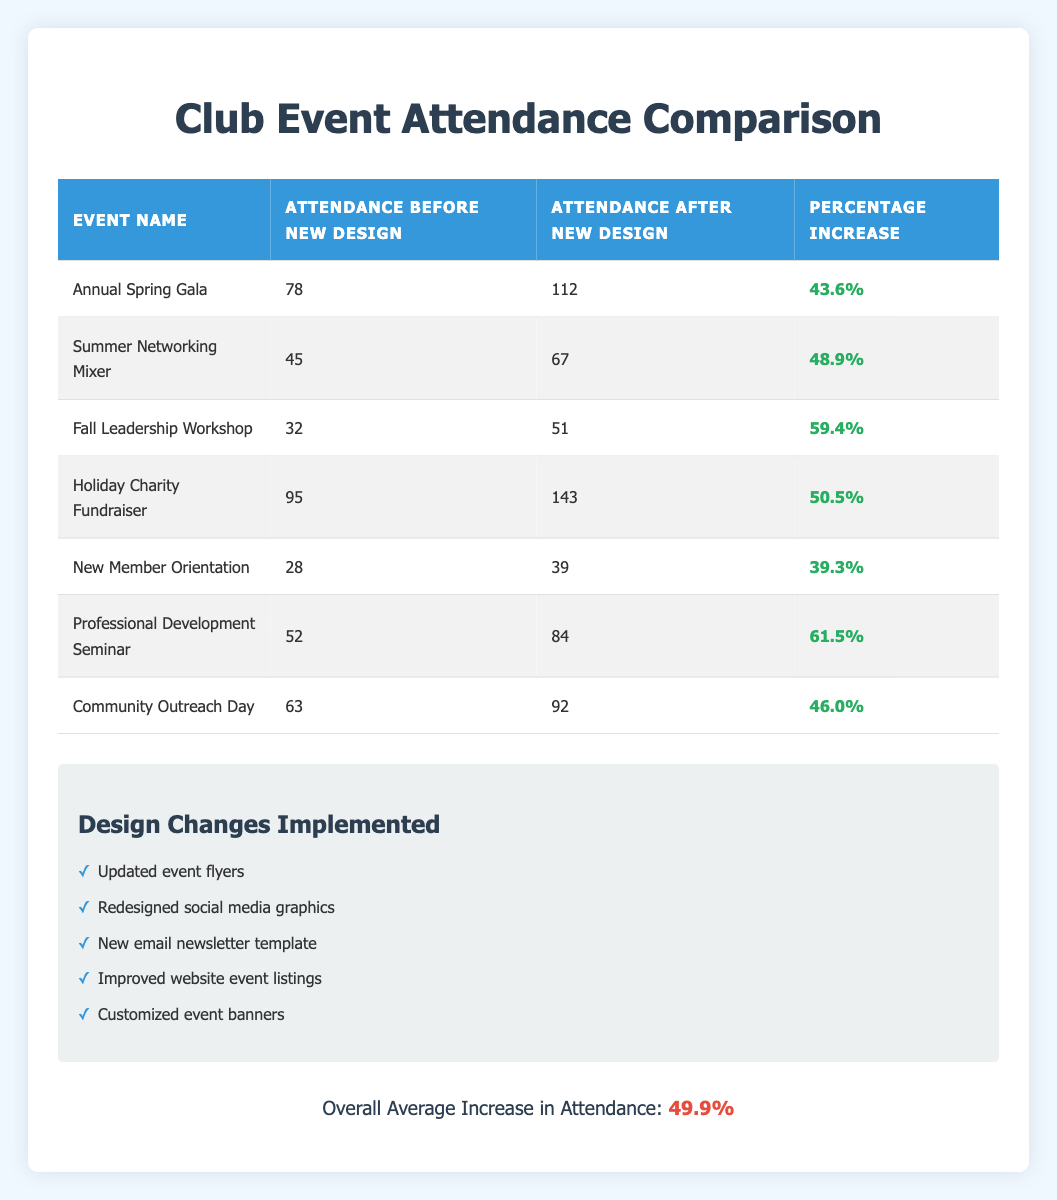What was the attendance for the Annual Spring Gala before the new design was implemented? The attendance before the new design for the Annual Spring Gala is explicitly stated in the table as 78.
Answer: 78 What design change was implemented for the Summer Networking Mixer? The table does not specify which specific design change was implemented for each event, so it would require knowledge outside the table.
Answer: Unknown How many attendees were present at the Fall Leadership Workshop after the redesign? The attendance after the new design for the Fall Leadership Workshop is shown as 51 in the table.
Answer: 51 What is the percentage increase in attendance for the Holiday Charity Fundraiser? The table indicates that the percentage increase for the Holiday Charity Fundraiser is 50.5%.
Answer: 50.5% Which event had the highest attendance increase percentage, and what was that percentage? Comparing the percentage increases, the Professional Development Seminar had the highest percentage increase of 61.5%.
Answer: Professional Development Seminar, 61.5% What is the overall average increase in attendance across all events listed? The overall average increase is given in the table as 49.9%, calculated based on individual event attendance changes.
Answer: 49.9% Is the attendance after the redesign for New Member Orientation greater than 40 attendees? The attendance after the redesign for New Member Orientation is 39, which is less than 40. Thus, the answer is no.
Answer: No What is the total attendance before the new design for all events combined? To calculate the total attendance before the new designs, sum the values in the "Attendance Before New Design" column: 78 + 45 + 32 + 95 + 28 + 52 + 63 = 393.
Answer: 393 Did the Community Outreach Day see a higher attendance increase than the Annual Spring Gala? The Community Outreach Day had an increase of 46.0%, while the Annual Spring Gala had an increase of 43.6%. Therefore, the increase for Community Outreach Day is higher.
Answer: Yes 